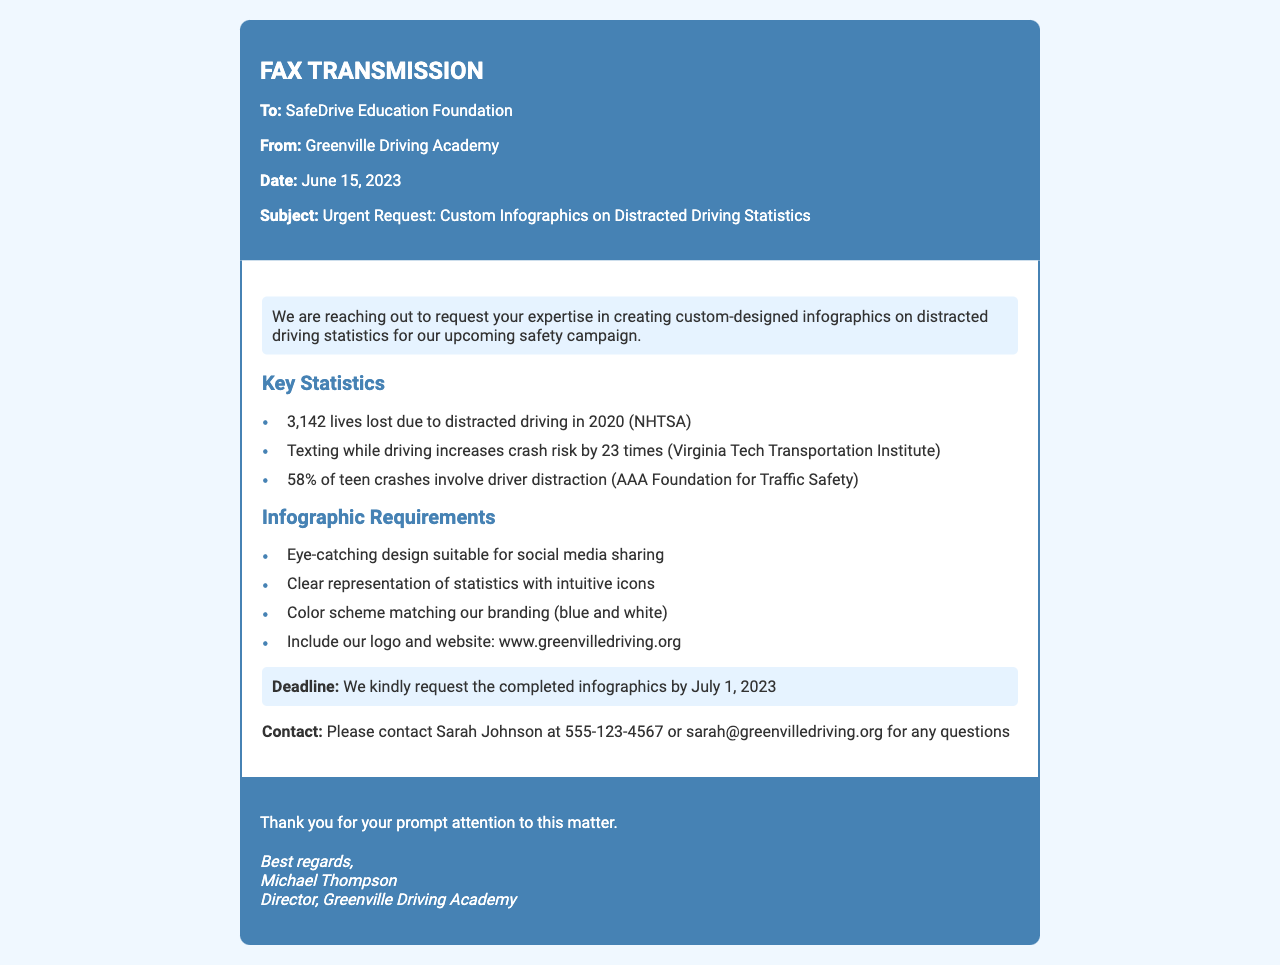What is the main purpose of the fax? The fax is a request for custom-designed infographics on distracted driving statistics for a safety campaign.
Answer: Request for custom-designed infographics Who is the sender of the fax? The sender is identified as the Greenville Driving Academy.
Answer: Greenville Driving Academy What is the deadline for the completed infographics? The requested completion date for the infographics is mentioned clearly in the document.
Answer: July 1, 2023 How many lives were lost due to distracted driving in 2020? This information is a specific statistic provided in the document regarding distracted driving incidents.
Answer: 3,142 What percentage of teen crashes involve driver distraction? This statistic highlights the impact of distraction among teen drivers as mentioned in the document.
Answer: 58% What color scheme should be used in the infographics? The required color scheme is specified to align with the sender’s branding in the document.
Answer: Blue and white Who should be contacted for questions regarding the request? Contact details are provided for the individual to reach out with queries about the infographics.
Answer: Sarah Johnson What type of design is requested for the infographics? The document specifies the kind of design suitable for the target audience of the campaign.
Answer: Eye-catching design suitable for social media sharing 